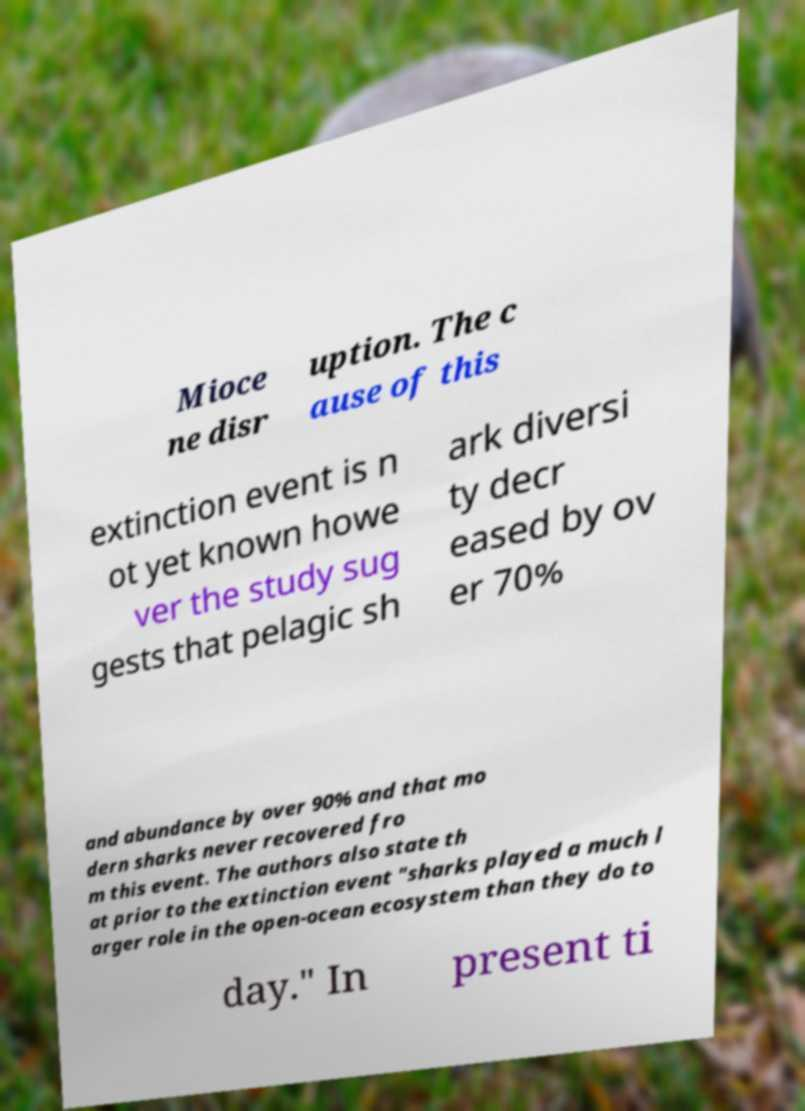What messages or text are displayed in this image? I need them in a readable, typed format. Mioce ne disr uption. The c ause of this extinction event is n ot yet known howe ver the study sug gests that pelagic sh ark diversi ty decr eased by ov er 70% and abundance by over 90% and that mo dern sharks never recovered fro m this event. The authors also state th at prior to the extinction event "sharks played a much l arger role in the open-ocean ecosystem than they do to day." In present ti 